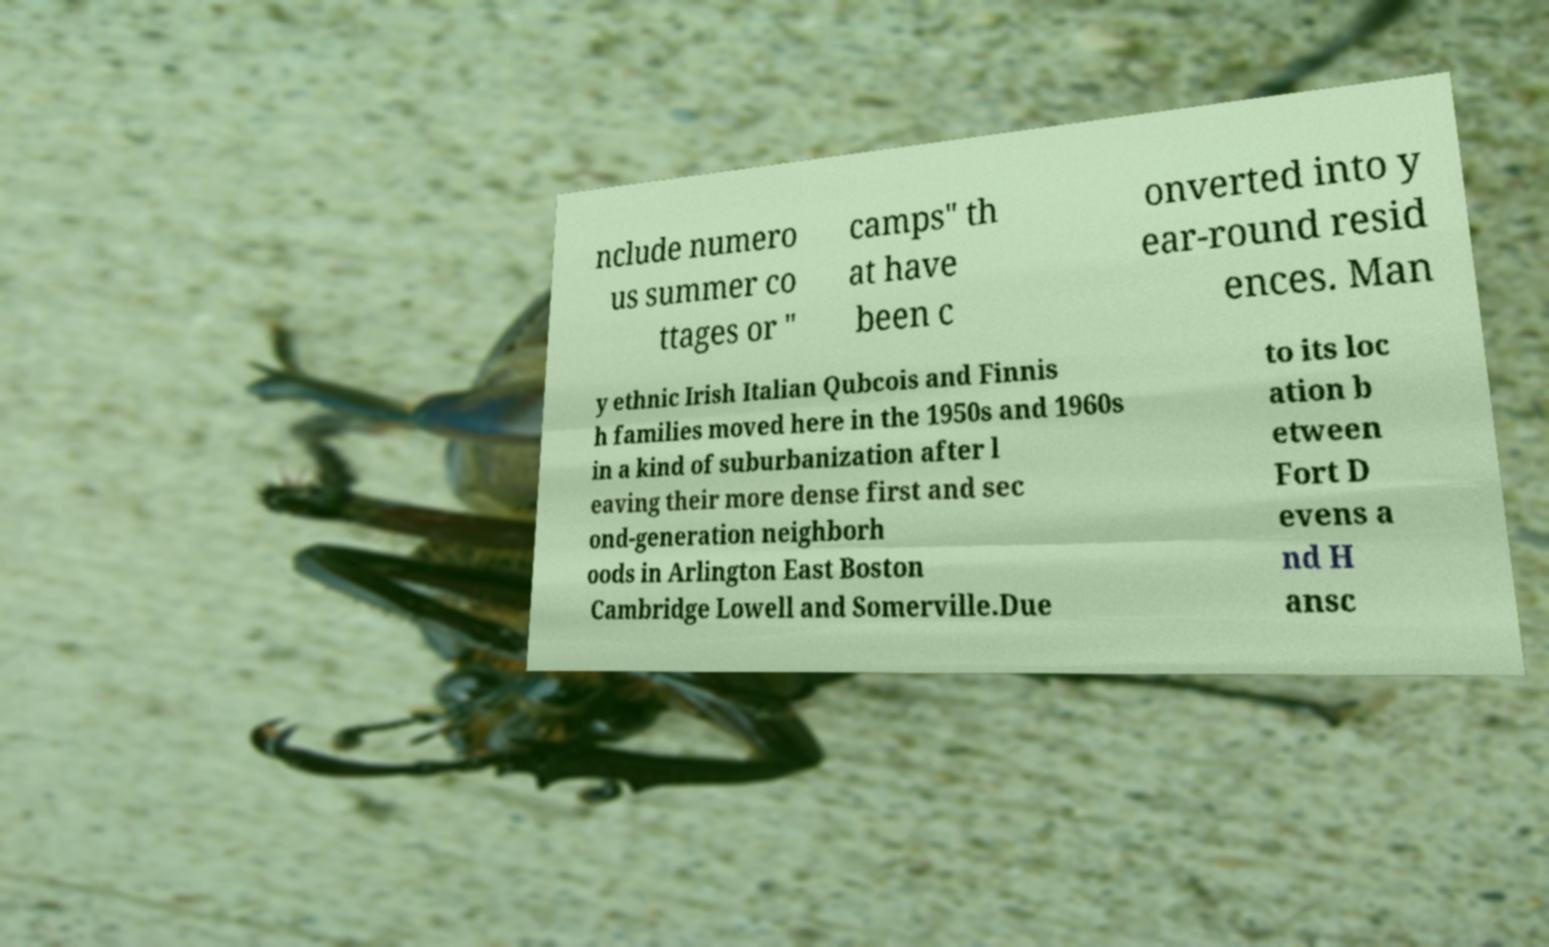Can you read and provide the text displayed in the image?This photo seems to have some interesting text. Can you extract and type it out for me? nclude numero us summer co ttages or " camps" th at have been c onverted into y ear-round resid ences. Man y ethnic Irish Italian Qubcois and Finnis h families moved here in the 1950s and 1960s in a kind of suburbanization after l eaving their more dense first and sec ond-generation neighborh oods in Arlington East Boston Cambridge Lowell and Somerville.Due to its loc ation b etween Fort D evens a nd H ansc 